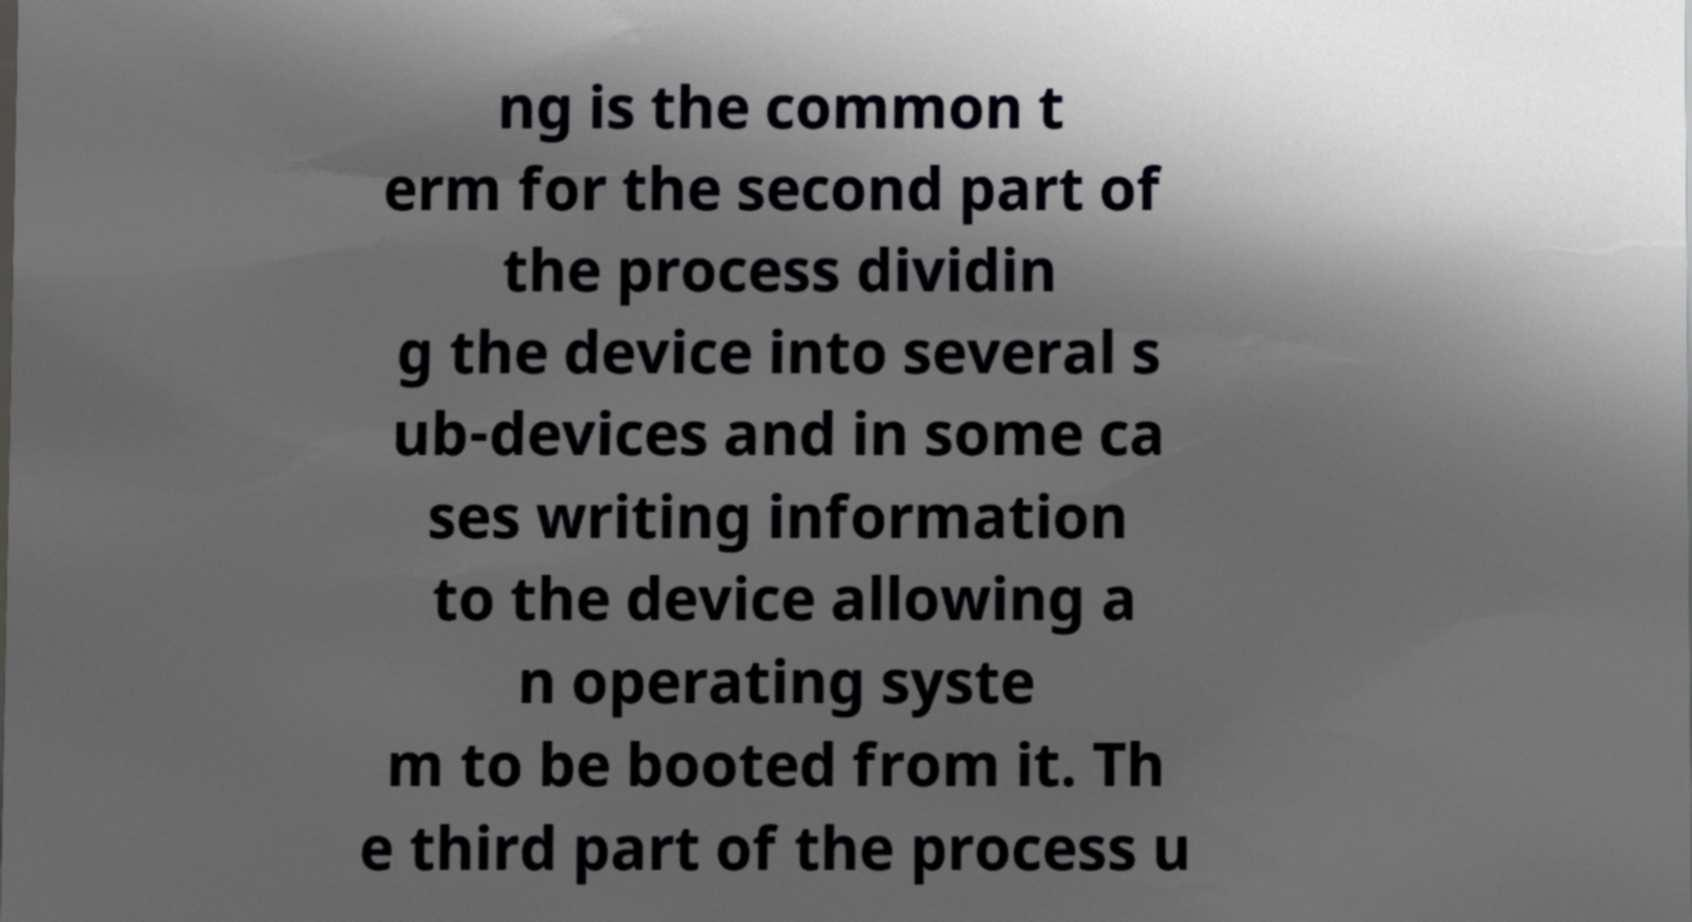Could you extract and type out the text from this image? ng is the common t erm for the second part of the process dividin g the device into several s ub-devices and in some ca ses writing information to the device allowing a n operating syste m to be booted from it. Th e third part of the process u 